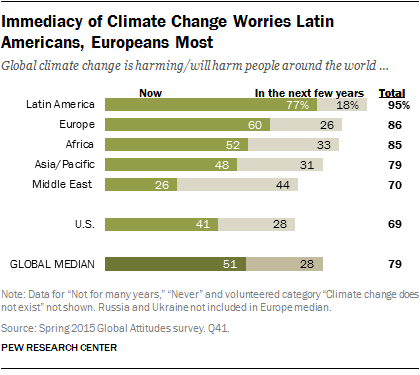Mention a couple of crucial points in this snapshot. Europe has 60% of the climate change problem, according to recent data. The total distribution of the US and the Middle East is 139. 